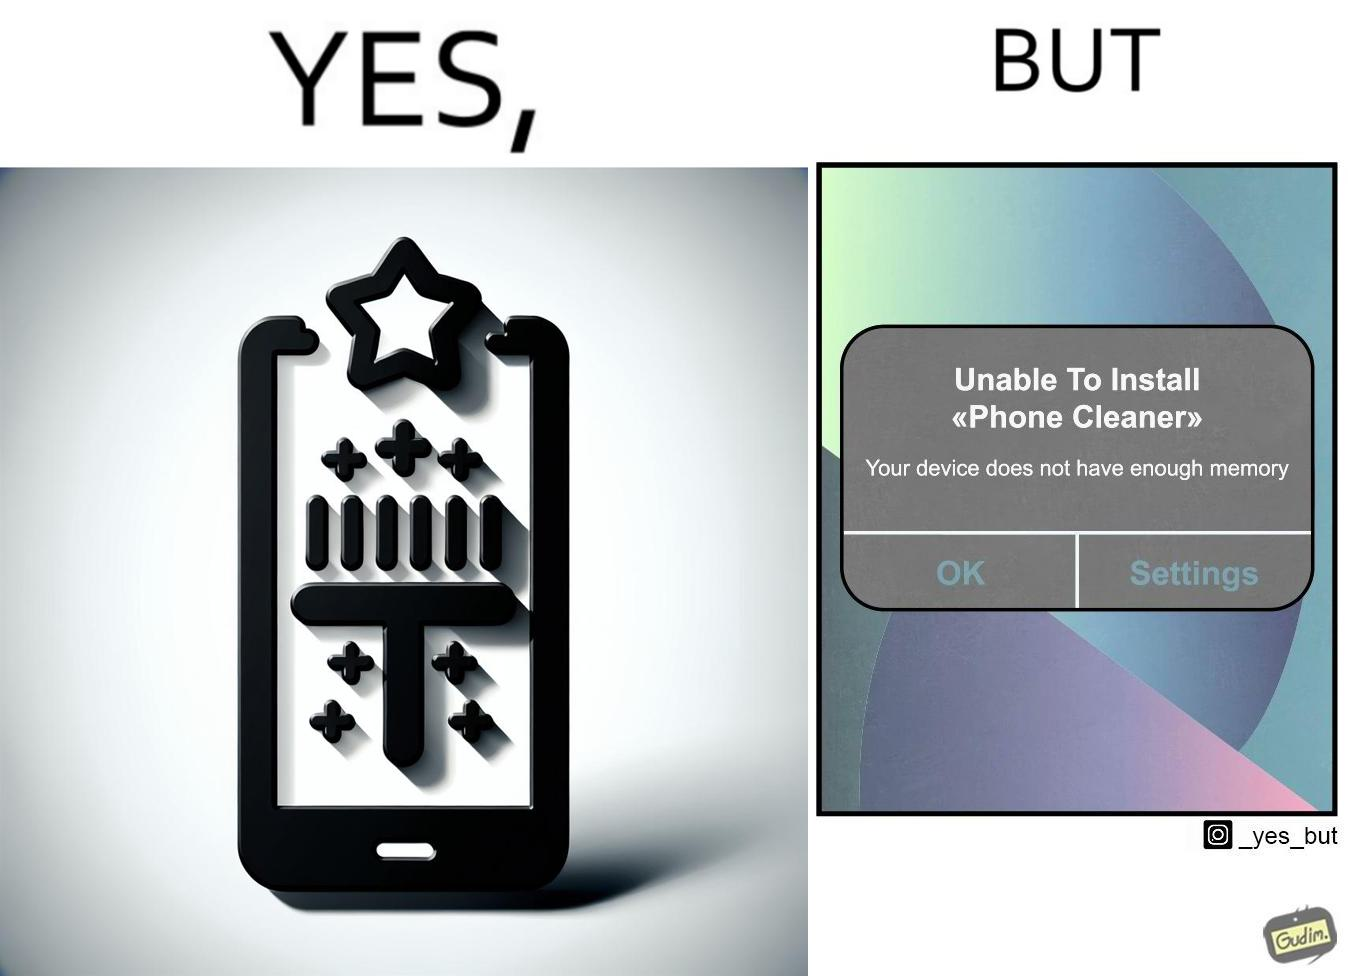What is shown in the left half versus the right half of this image? In the left part of the image: Phone cleaner app for cleaning phone memory, with a 4+ star rating. In the right part of the image: A pop-up message on a mobile device, showing that it is unable to install an app named "Phone cleaner" that due to insufficient availability of memory on the device. 